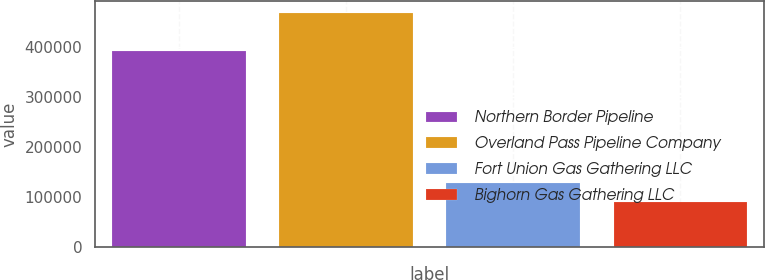<chart> <loc_0><loc_0><loc_500><loc_500><bar_chart><fcel>Northern Border Pipeline<fcel>Overland Pass Pipeline Company<fcel>Fort Union Gas Gathering LLC<fcel>Bighorn Gas Gathering LLC<nl><fcel>393317<fcel>468710<fcel>128256<fcel>90428<nl></chart> 